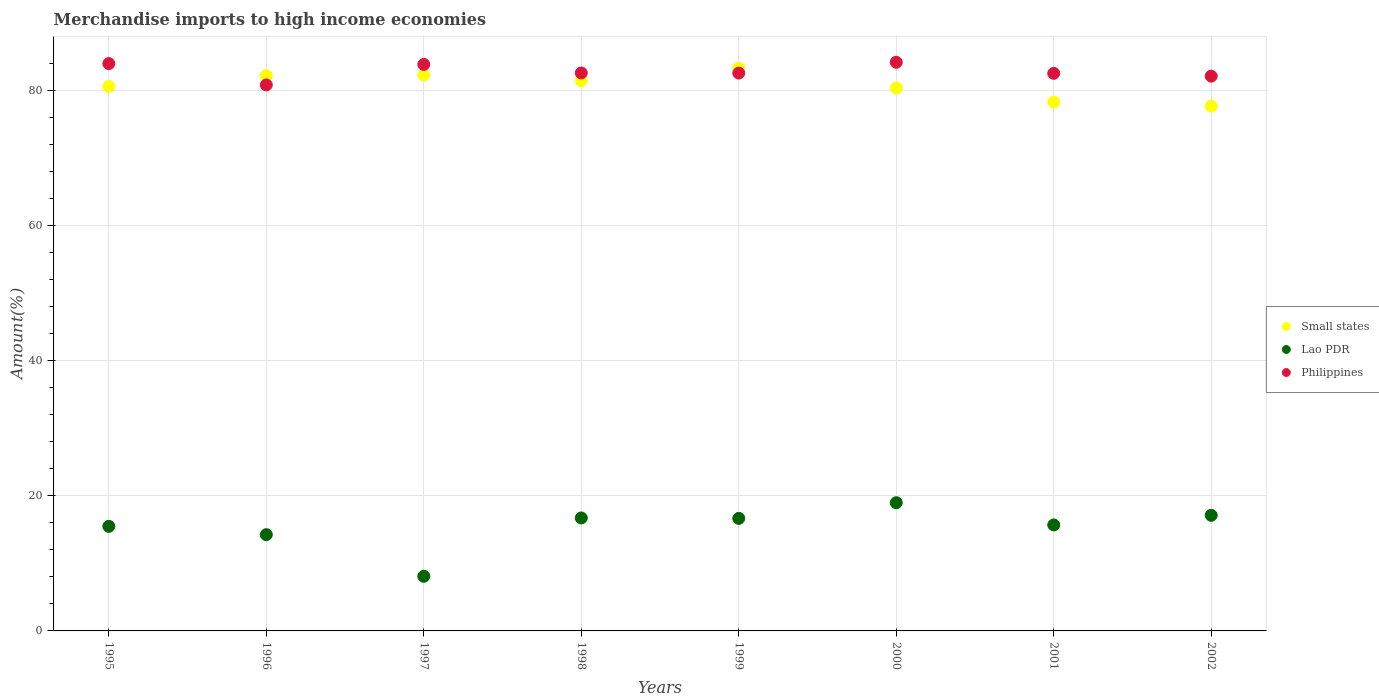What is the percentage of amount earned from merchandise imports in Lao PDR in 1997?
Your answer should be compact. 8.09. Across all years, what is the maximum percentage of amount earned from merchandise imports in Lao PDR?
Offer a terse response. 18.97. Across all years, what is the minimum percentage of amount earned from merchandise imports in Lao PDR?
Offer a very short reply. 8.09. In which year was the percentage of amount earned from merchandise imports in Small states maximum?
Your answer should be very brief. 1999. What is the total percentage of amount earned from merchandise imports in Small states in the graph?
Offer a very short reply. 645.89. What is the difference between the percentage of amount earned from merchandise imports in Small states in 1995 and that in 2002?
Your answer should be compact. 2.91. What is the difference between the percentage of amount earned from merchandise imports in Lao PDR in 2001 and the percentage of amount earned from merchandise imports in Philippines in 1996?
Provide a short and direct response. -65.1. What is the average percentage of amount earned from merchandise imports in Small states per year?
Give a very brief answer. 80.74. In the year 2002, what is the difference between the percentage of amount earned from merchandise imports in Small states and percentage of amount earned from merchandise imports in Philippines?
Your answer should be compact. -4.42. What is the ratio of the percentage of amount earned from merchandise imports in Lao PDR in 1997 to that in 2001?
Offer a very short reply. 0.52. What is the difference between the highest and the second highest percentage of amount earned from merchandise imports in Philippines?
Your answer should be compact. 0.19. What is the difference between the highest and the lowest percentage of amount earned from merchandise imports in Philippines?
Offer a terse response. 3.35. In how many years, is the percentage of amount earned from merchandise imports in Philippines greater than the average percentage of amount earned from merchandise imports in Philippines taken over all years?
Give a very brief answer. 3. Is the sum of the percentage of amount earned from merchandise imports in Small states in 1998 and 1999 greater than the maximum percentage of amount earned from merchandise imports in Philippines across all years?
Provide a succinct answer. Yes. Does the percentage of amount earned from merchandise imports in Small states monotonically increase over the years?
Keep it short and to the point. No. How many dotlines are there?
Offer a terse response. 3. How many years are there in the graph?
Offer a terse response. 8. What is the difference between two consecutive major ticks on the Y-axis?
Your response must be concise. 20. Does the graph contain any zero values?
Provide a succinct answer. No. Does the graph contain grids?
Provide a short and direct response. Yes. Where does the legend appear in the graph?
Your answer should be very brief. Center right. How are the legend labels stacked?
Offer a very short reply. Vertical. What is the title of the graph?
Your response must be concise. Merchandise imports to high income economies. Does "Nepal" appear as one of the legend labels in the graph?
Give a very brief answer. No. What is the label or title of the X-axis?
Your answer should be very brief. Years. What is the label or title of the Y-axis?
Ensure brevity in your answer.  Amount(%). What is the Amount(%) in Small states in 1995?
Provide a succinct answer. 80.57. What is the Amount(%) of Lao PDR in 1995?
Offer a very short reply. 15.47. What is the Amount(%) in Philippines in 1995?
Make the answer very short. 83.94. What is the Amount(%) of Small states in 1996?
Offer a terse response. 82.17. What is the Amount(%) in Lao PDR in 1996?
Your answer should be very brief. 14.24. What is the Amount(%) of Philippines in 1996?
Give a very brief answer. 80.78. What is the Amount(%) of Small states in 1997?
Offer a very short reply. 82.26. What is the Amount(%) of Lao PDR in 1997?
Provide a short and direct response. 8.09. What is the Amount(%) of Philippines in 1997?
Your answer should be compact. 83.81. What is the Amount(%) of Small states in 1998?
Provide a short and direct response. 81.41. What is the Amount(%) in Lao PDR in 1998?
Your response must be concise. 16.71. What is the Amount(%) of Philippines in 1998?
Keep it short and to the point. 82.56. What is the Amount(%) in Small states in 1999?
Provide a succinct answer. 83.25. What is the Amount(%) in Lao PDR in 1999?
Your answer should be compact. 16.65. What is the Amount(%) of Philippines in 1999?
Provide a succinct answer. 82.54. What is the Amount(%) in Small states in 2000?
Provide a succinct answer. 80.33. What is the Amount(%) in Lao PDR in 2000?
Make the answer very short. 18.97. What is the Amount(%) of Philippines in 2000?
Ensure brevity in your answer.  84.14. What is the Amount(%) of Small states in 2001?
Provide a succinct answer. 78.24. What is the Amount(%) in Lao PDR in 2001?
Make the answer very short. 15.68. What is the Amount(%) in Philippines in 2001?
Make the answer very short. 82.5. What is the Amount(%) of Small states in 2002?
Ensure brevity in your answer.  77.66. What is the Amount(%) in Lao PDR in 2002?
Offer a terse response. 17.1. What is the Amount(%) in Philippines in 2002?
Keep it short and to the point. 82.08. Across all years, what is the maximum Amount(%) of Small states?
Your response must be concise. 83.25. Across all years, what is the maximum Amount(%) in Lao PDR?
Provide a short and direct response. 18.97. Across all years, what is the maximum Amount(%) of Philippines?
Offer a terse response. 84.14. Across all years, what is the minimum Amount(%) in Small states?
Make the answer very short. 77.66. Across all years, what is the minimum Amount(%) in Lao PDR?
Provide a succinct answer. 8.09. Across all years, what is the minimum Amount(%) in Philippines?
Offer a very short reply. 80.78. What is the total Amount(%) of Small states in the graph?
Offer a terse response. 645.89. What is the total Amount(%) of Lao PDR in the graph?
Make the answer very short. 122.92. What is the total Amount(%) in Philippines in the graph?
Offer a very short reply. 662.35. What is the difference between the Amount(%) of Small states in 1995 and that in 1996?
Your answer should be compact. -1.61. What is the difference between the Amount(%) of Lao PDR in 1995 and that in 1996?
Your answer should be compact. 1.23. What is the difference between the Amount(%) in Philippines in 1995 and that in 1996?
Keep it short and to the point. 3.16. What is the difference between the Amount(%) of Small states in 1995 and that in 1997?
Your answer should be very brief. -1.69. What is the difference between the Amount(%) of Lao PDR in 1995 and that in 1997?
Ensure brevity in your answer.  7.39. What is the difference between the Amount(%) in Philippines in 1995 and that in 1997?
Offer a very short reply. 0.13. What is the difference between the Amount(%) in Small states in 1995 and that in 1998?
Provide a short and direct response. -0.85. What is the difference between the Amount(%) in Lao PDR in 1995 and that in 1998?
Your answer should be compact. -1.24. What is the difference between the Amount(%) in Philippines in 1995 and that in 1998?
Your answer should be compact. 1.39. What is the difference between the Amount(%) in Small states in 1995 and that in 1999?
Provide a short and direct response. -2.68. What is the difference between the Amount(%) in Lao PDR in 1995 and that in 1999?
Your response must be concise. -1.18. What is the difference between the Amount(%) of Philippines in 1995 and that in 1999?
Offer a very short reply. 1.41. What is the difference between the Amount(%) in Small states in 1995 and that in 2000?
Make the answer very short. 0.24. What is the difference between the Amount(%) of Lao PDR in 1995 and that in 2000?
Ensure brevity in your answer.  -3.5. What is the difference between the Amount(%) of Philippines in 1995 and that in 2000?
Offer a very short reply. -0.19. What is the difference between the Amount(%) in Small states in 1995 and that in 2001?
Provide a short and direct response. 2.32. What is the difference between the Amount(%) in Lao PDR in 1995 and that in 2001?
Your answer should be very brief. -0.21. What is the difference between the Amount(%) of Philippines in 1995 and that in 2001?
Your answer should be compact. 1.45. What is the difference between the Amount(%) of Small states in 1995 and that in 2002?
Offer a very short reply. 2.91. What is the difference between the Amount(%) of Lao PDR in 1995 and that in 2002?
Ensure brevity in your answer.  -1.63. What is the difference between the Amount(%) in Philippines in 1995 and that in 2002?
Provide a succinct answer. 1.86. What is the difference between the Amount(%) of Small states in 1996 and that in 1997?
Offer a very short reply. -0.08. What is the difference between the Amount(%) in Lao PDR in 1996 and that in 1997?
Provide a short and direct response. 6.15. What is the difference between the Amount(%) of Philippines in 1996 and that in 1997?
Give a very brief answer. -3.03. What is the difference between the Amount(%) of Small states in 1996 and that in 1998?
Your answer should be compact. 0.76. What is the difference between the Amount(%) in Lao PDR in 1996 and that in 1998?
Your answer should be very brief. -2.47. What is the difference between the Amount(%) in Philippines in 1996 and that in 1998?
Make the answer very short. -1.77. What is the difference between the Amount(%) in Small states in 1996 and that in 1999?
Give a very brief answer. -1.08. What is the difference between the Amount(%) in Lao PDR in 1996 and that in 1999?
Provide a short and direct response. -2.41. What is the difference between the Amount(%) in Philippines in 1996 and that in 1999?
Keep it short and to the point. -1.75. What is the difference between the Amount(%) of Small states in 1996 and that in 2000?
Provide a short and direct response. 1.85. What is the difference between the Amount(%) in Lao PDR in 1996 and that in 2000?
Offer a very short reply. -4.73. What is the difference between the Amount(%) in Philippines in 1996 and that in 2000?
Your answer should be compact. -3.35. What is the difference between the Amount(%) in Small states in 1996 and that in 2001?
Your answer should be compact. 3.93. What is the difference between the Amount(%) of Lao PDR in 1996 and that in 2001?
Make the answer very short. -1.44. What is the difference between the Amount(%) of Philippines in 1996 and that in 2001?
Offer a terse response. -1.72. What is the difference between the Amount(%) of Small states in 1996 and that in 2002?
Make the answer very short. 4.51. What is the difference between the Amount(%) in Lao PDR in 1996 and that in 2002?
Provide a short and direct response. -2.86. What is the difference between the Amount(%) of Philippines in 1996 and that in 2002?
Offer a very short reply. -1.3. What is the difference between the Amount(%) of Small states in 1997 and that in 1998?
Ensure brevity in your answer.  0.85. What is the difference between the Amount(%) in Lao PDR in 1997 and that in 1998?
Your answer should be compact. -8.63. What is the difference between the Amount(%) of Philippines in 1997 and that in 1998?
Keep it short and to the point. 1.26. What is the difference between the Amount(%) of Small states in 1997 and that in 1999?
Your response must be concise. -0.99. What is the difference between the Amount(%) in Lao PDR in 1997 and that in 1999?
Give a very brief answer. -8.57. What is the difference between the Amount(%) of Philippines in 1997 and that in 1999?
Provide a short and direct response. 1.28. What is the difference between the Amount(%) in Small states in 1997 and that in 2000?
Your response must be concise. 1.93. What is the difference between the Amount(%) of Lao PDR in 1997 and that in 2000?
Provide a succinct answer. -10.89. What is the difference between the Amount(%) of Philippines in 1997 and that in 2000?
Give a very brief answer. -0.32. What is the difference between the Amount(%) in Small states in 1997 and that in 2001?
Give a very brief answer. 4.02. What is the difference between the Amount(%) in Lao PDR in 1997 and that in 2001?
Offer a very short reply. -7.6. What is the difference between the Amount(%) of Philippines in 1997 and that in 2001?
Make the answer very short. 1.32. What is the difference between the Amount(%) in Small states in 1997 and that in 2002?
Make the answer very short. 4.6. What is the difference between the Amount(%) of Lao PDR in 1997 and that in 2002?
Make the answer very short. -9.02. What is the difference between the Amount(%) of Philippines in 1997 and that in 2002?
Ensure brevity in your answer.  1.73. What is the difference between the Amount(%) of Small states in 1998 and that in 1999?
Ensure brevity in your answer.  -1.84. What is the difference between the Amount(%) of Lao PDR in 1998 and that in 1999?
Your answer should be very brief. 0.06. What is the difference between the Amount(%) of Philippines in 1998 and that in 1999?
Your answer should be very brief. 0.02. What is the difference between the Amount(%) in Small states in 1998 and that in 2000?
Make the answer very short. 1.09. What is the difference between the Amount(%) in Lao PDR in 1998 and that in 2000?
Offer a very short reply. -2.26. What is the difference between the Amount(%) of Philippines in 1998 and that in 2000?
Your response must be concise. -1.58. What is the difference between the Amount(%) of Small states in 1998 and that in 2001?
Give a very brief answer. 3.17. What is the difference between the Amount(%) of Lao PDR in 1998 and that in 2001?
Offer a very short reply. 1.03. What is the difference between the Amount(%) of Philippines in 1998 and that in 2001?
Offer a very short reply. 0.06. What is the difference between the Amount(%) of Small states in 1998 and that in 2002?
Provide a succinct answer. 3.75. What is the difference between the Amount(%) in Lao PDR in 1998 and that in 2002?
Give a very brief answer. -0.39. What is the difference between the Amount(%) of Philippines in 1998 and that in 2002?
Provide a short and direct response. 0.47. What is the difference between the Amount(%) of Small states in 1999 and that in 2000?
Give a very brief answer. 2.92. What is the difference between the Amount(%) in Lao PDR in 1999 and that in 2000?
Offer a very short reply. -2.32. What is the difference between the Amount(%) of Philippines in 1999 and that in 2000?
Ensure brevity in your answer.  -1.6. What is the difference between the Amount(%) in Small states in 1999 and that in 2001?
Offer a terse response. 5.01. What is the difference between the Amount(%) in Lao PDR in 1999 and that in 2001?
Your response must be concise. 0.97. What is the difference between the Amount(%) in Philippines in 1999 and that in 2001?
Your answer should be compact. 0.04. What is the difference between the Amount(%) of Small states in 1999 and that in 2002?
Your answer should be compact. 5.59. What is the difference between the Amount(%) in Lao PDR in 1999 and that in 2002?
Offer a very short reply. -0.45. What is the difference between the Amount(%) of Philippines in 1999 and that in 2002?
Keep it short and to the point. 0.45. What is the difference between the Amount(%) in Small states in 2000 and that in 2001?
Offer a very short reply. 2.08. What is the difference between the Amount(%) in Lao PDR in 2000 and that in 2001?
Offer a terse response. 3.29. What is the difference between the Amount(%) of Philippines in 2000 and that in 2001?
Your response must be concise. 1.64. What is the difference between the Amount(%) of Small states in 2000 and that in 2002?
Provide a succinct answer. 2.67. What is the difference between the Amount(%) of Lao PDR in 2000 and that in 2002?
Your answer should be compact. 1.87. What is the difference between the Amount(%) in Philippines in 2000 and that in 2002?
Ensure brevity in your answer.  2.05. What is the difference between the Amount(%) in Small states in 2001 and that in 2002?
Provide a succinct answer. 0.58. What is the difference between the Amount(%) of Lao PDR in 2001 and that in 2002?
Keep it short and to the point. -1.42. What is the difference between the Amount(%) of Philippines in 2001 and that in 2002?
Your answer should be compact. 0.41. What is the difference between the Amount(%) of Small states in 1995 and the Amount(%) of Lao PDR in 1996?
Offer a very short reply. 66.33. What is the difference between the Amount(%) in Small states in 1995 and the Amount(%) in Philippines in 1996?
Provide a succinct answer. -0.22. What is the difference between the Amount(%) in Lao PDR in 1995 and the Amount(%) in Philippines in 1996?
Offer a very short reply. -65.31. What is the difference between the Amount(%) of Small states in 1995 and the Amount(%) of Lao PDR in 1997?
Give a very brief answer. 72.48. What is the difference between the Amount(%) in Small states in 1995 and the Amount(%) in Philippines in 1997?
Offer a very short reply. -3.25. What is the difference between the Amount(%) of Lao PDR in 1995 and the Amount(%) of Philippines in 1997?
Ensure brevity in your answer.  -68.34. What is the difference between the Amount(%) in Small states in 1995 and the Amount(%) in Lao PDR in 1998?
Provide a short and direct response. 63.85. What is the difference between the Amount(%) in Small states in 1995 and the Amount(%) in Philippines in 1998?
Your answer should be very brief. -1.99. What is the difference between the Amount(%) in Lao PDR in 1995 and the Amount(%) in Philippines in 1998?
Give a very brief answer. -67.08. What is the difference between the Amount(%) in Small states in 1995 and the Amount(%) in Lao PDR in 1999?
Your answer should be very brief. 63.91. What is the difference between the Amount(%) of Small states in 1995 and the Amount(%) of Philippines in 1999?
Provide a short and direct response. -1.97. What is the difference between the Amount(%) in Lao PDR in 1995 and the Amount(%) in Philippines in 1999?
Your answer should be compact. -67.06. What is the difference between the Amount(%) of Small states in 1995 and the Amount(%) of Lao PDR in 2000?
Your response must be concise. 61.59. What is the difference between the Amount(%) of Small states in 1995 and the Amount(%) of Philippines in 2000?
Your answer should be compact. -3.57. What is the difference between the Amount(%) in Lao PDR in 1995 and the Amount(%) in Philippines in 2000?
Make the answer very short. -68.66. What is the difference between the Amount(%) of Small states in 1995 and the Amount(%) of Lao PDR in 2001?
Keep it short and to the point. 64.88. What is the difference between the Amount(%) of Small states in 1995 and the Amount(%) of Philippines in 2001?
Make the answer very short. -1.93. What is the difference between the Amount(%) of Lao PDR in 1995 and the Amount(%) of Philippines in 2001?
Offer a very short reply. -67.03. What is the difference between the Amount(%) in Small states in 1995 and the Amount(%) in Lao PDR in 2002?
Keep it short and to the point. 63.46. What is the difference between the Amount(%) in Small states in 1995 and the Amount(%) in Philippines in 2002?
Your response must be concise. -1.52. What is the difference between the Amount(%) in Lao PDR in 1995 and the Amount(%) in Philippines in 2002?
Your answer should be compact. -66.61. What is the difference between the Amount(%) of Small states in 1996 and the Amount(%) of Lao PDR in 1997?
Offer a very short reply. 74.09. What is the difference between the Amount(%) of Small states in 1996 and the Amount(%) of Philippines in 1997?
Provide a short and direct response. -1.64. What is the difference between the Amount(%) of Lao PDR in 1996 and the Amount(%) of Philippines in 1997?
Your answer should be compact. -69.57. What is the difference between the Amount(%) in Small states in 1996 and the Amount(%) in Lao PDR in 1998?
Provide a succinct answer. 65.46. What is the difference between the Amount(%) in Small states in 1996 and the Amount(%) in Philippines in 1998?
Keep it short and to the point. -0.38. What is the difference between the Amount(%) in Lao PDR in 1996 and the Amount(%) in Philippines in 1998?
Give a very brief answer. -68.32. What is the difference between the Amount(%) in Small states in 1996 and the Amount(%) in Lao PDR in 1999?
Give a very brief answer. 65.52. What is the difference between the Amount(%) of Small states in 1996 and the Amount(%) of Philippines in 1999?
Offer a very short reply. -0.36. What is the difference between the Amount(%) in Lao PDR in 1996 and the Amount(%) in Philippines in 1999?
Offer a very short reply. -68.3. What is the difference between the Amount(%) in Small states in 1996 and the Amount(%) in Lao PDR in 2000?
Ensure brevity in your answer.  63.2. What is the difference between the Amount(%) in Small states in 1996 and the Amount(%) in Philippines in 2000?
Make the answer very short. -1.96. What is the difference between the Amount(%) of Lao PDR in 1996 and the Amount(%) of Philippines in 2000?
Give a very brief answer. -69.9. What is the difference between the Amount(%) of Small states in 1996 and the Amount(%) of Lao PDR in 2001?
Offer a terse response. 66.49. What is the difference between the Amount(%) in Small states in 1996 and the Amount(%) in Philippines in 2001?
Offer a terse response. -0.32. What is the difference between the Amount(%) in Lao PDR in 1996 and the Amount(%) in Philippines in 2001?
Your response must be concise. -68.26. What is the difference between the Amount(%) in Small states in 1996 and the Amount(%) in Lao PDR in 2002?
Ensure brevity in your answer.  65.07. What is the difference between the Amount(%) in Small states in 1996 and the Amount(%) in Philippines in 2002?
Offer a terse response. 0.09. What is the difference between the Amount(%) in Lao PDR in 1996 and the Amount(%) in Philippines in 2002?
Your answer should be very brief. -67.84. What is the difference between the Amount(%) of Small states in 1997 and the Amount(%) of Lao PDR in 1998?
Offer a terse response. 65.55. What is the difference between the Amount(%) in Small states in 1997 and the Amount(%) in Philippines in 1998?
Give a very brief answer. -0.3. What is the difference between the Amount(%) of Lao PDR in 1997 and the Amount(%) of Philippines in 1998?
Keep it short and to the point. -74.47. What is the difference between the Amount(%) of Small states in 1997 and the Amount(%) of Lao PDR in 1999?
Your answer should be compact. 65.61. What is the difference between the Amount(%) in Small states in 1997 and the Amount(%) in Philippines in 1999?
Ensure brevity in your answer.  -0.28. What is the difference between the Amount(%) of Lao PDR in 1997 and the Amount(%) of Philippines in 1999?
Keep it short and to the point. -74.45. What is the difference between the Amount(%) of Small states in 1997 and the Amount(%) of Lao PDR in 2000?
Your answer should be very brief. 63.29. What is the difference between the Amount(%) of Small states in 1997 and the Amount(%) of Philippines in 2000?
Give a very brief answer. -1.88. What is the difference between the Amount(%) in Lao PDR in 1997 and the Amount(%) in Philippines in 2000?
Provide a succinct answer. -76.05. What is the difference between the Amount(%) of Small states in 1997 and the Amount(%) of Lao PDR in 2001?
Provide a short and direct response. 66.58. What is the difference between the Amount(%) of Small states in 1997 and the Amount(%) of Philippines in 2001?
Your response must be concise. -0.24. What is the difference between the Amount(%) in Lao PDR in 1997 and the Amount(%) in Philippines in 2001?
Ensure brevity in your answer.  -74.41. What is the difference between the Amount(%) of Small states in 1997 and the Amount(%) of Lao PDR in 2002?
Your answer should be compact. 65.16. What is the difference between the Amount(%) in Small states in 1997 and the Amount(%) in Philippines in 2002?
Your answer should be very brief. 0.18. What is the difference between the Amount(%) of Lao PDR in 1997 and the Amount(%) of Philippines in 2002?
Your answer should be very brief. -74. What is the difference between the Amount(%) in Small states in 1998 and the Amount(%) in Lao PDR in 1999?
Give a very brief answer. 64.76. What is the difference between the Amount(%) in Small states in 1998 and the Amount(%) in Philippines in 1999?
Give a very brief answer. -1.12. What is the difference between the Amount(%) of Lao PDR in 1998 and the Amount(%) of Philippines in 1999?
Offer a terse response. -65.82. What is the difference between the Amount(%) of Small states in 1998 and the Amount(%) of Lao PDR in 2000?
Offer a very short reply. 62.44. What is the difference between the Amount(%) of Small states in 1998 and the Amount(%) of Philippines in 2000?
Provide a succinct answer. -2.72. What is the difference between the Amount(%) of Lao PDR in 1998 and the Amount(%) of Philippines in 2000?
Your response must be concise. -67.42. What is the difference between the Amount(%) of Small states in 1998 and the Amount(%) of Lao PDR in 2001?
Ensure brevity in your answer.  65.73. What is the difference between the Amount(%) in Small states in 1998 and the Amount(%) in Philippines in 2001?
Offer a terse response. -1.09. What is the difference between the Amount(%) of Lao PDR in 1998 and the Amount(%) of Philippines in 2001?
Give a very brief answer. -65.78. What is the difference between the Amount(%) in Small states in 1998 and the Amount(%) in Lao PDR in 2002?
Your answer should be compact. 64.31. What is the difference between the Amount(%) in Small states in 1998 and the Amount(%) in Philippines in 2002?
Give a very brief answer. -0.67. What is the difference between the Amount(%) in Lao PDR in 1998 and the Amount(%) in Philippines in 2002?
Provide a short and direct response. -65.37. What is the difference between the Amount(%) in Small states in 1999 and the Amount(%) in Lao PDR in 2000?
Your answer should be compact. 64.28. What is the difference between the Amount(%) of Small states in 1999 and the Amount(%) of Philippines in 2000?
Your answer should be compact. -0.89. What is the difference between the Amount(%) of Lao PDR in 1999 and the Amount(%) of Philippines in 2000?
Give a very brief answer. -67.48. What is the difference between the Amount(%) of Small states in 1999 and the Amount(%) of Lao PDR in 2001?
Provide a succinct answer. 67.57. What is the difference between the Amount(%) of Small states in 1999 and the Amount(%) of Philippines in 2001?
Keep it short and to the point. 0.75. What is the difference between the Amount(%) in Lao PDR in 1999 and the Amount(%) in Philippines in 2001?
Give a very brief answer. -65.85. What is the difference between the Amount(%) in Small states in 1999 and the Amount(%) in Lao PDR in 2002?
Provide a succinct answer. 66.15. What is the difference between the Amount(%) in Small states in 1999 and the Amount(%) in Philippines in 2002?
Offer a terse response. 1.17. What is the difference between the Amount(%) of Lao PDR in 1999 and the Amount(%) of Philippines in 2002?
Give a very brief answer. -65.43. What is the difference between the Amount(%) of Small states in 2000 and the Amount(%) of Lao PDR in 2001?
Keep it short and to the point. 64.64. What is the difference between the Amount(%) of Small states in 2000 and the Amount(%) of Philippines in 2001?
Offer a very short reply. -2.17. What is the difference between the Amount(%) of Lao PDR in 2000 and the Amount(%) of Philippines in 2001?
Your response must be concise. -63.53. What is the difference between the Amount(%) in Small states in 2000 and the Amount(%) in Lao PDR in 2002?
Keep it short and to the point. 63.22. What is the difference between the Amount(%) in Small states in 2000 and the Amount(%) in Philippines in 2002?
Make the answer very short. -1.76. What is the difference between the Amount(%) in Lao PDR in 2000 and the Amount(%) in Philippines in 2002?
Keep it short and to the point. -63.11. What is the difference between the Amount(%) in Small states in 2001 and the Amount(%) in Lao PDR in 2002?
Keep it short and to the point. 61.14. What is the difference between the Amount(%) in Small states in 2001 and the Amount(%) in Philippines in 2002?
Ensure brevity in your answer.  -3.84. What is the difference between the Amount(%) of Lao PDR in 2001 and the Amount(%) of Philippines in 2002?
Your response must be concise. -66.4. What is the average Amount(%) in Small states per year?
Your answer should be compact. 80.74. What is the average Amount(%) in Lao PDR per year?
Provide a short and direct response. 15.36. What is the average Amount(%) in Philippines per year?
Ensure brevity in your answer.  82.79. In the year 1995, what is the difference between the Amount(%) in Small states and Amount(%) in Lao PDR?
Keep it short and to the point. 65.09. In the year 1995, what is the difference between the Amount(%) in Small states and Amount(%) in Philippines?
Offer a terse response. -3.38. In the year 1995, what is the difference between the Amount(%) in Lao PDR and Amount(%) in Philippines?
Offer a terse response. -68.47. In the year 1996, what is the difference between the Amount(%) of Small states and Amount(%) of Lao PDR?
Make the answer very short. 67.93. In the year 1996, what is the difference between the Amount(%) in Small states and Amount(%) in Philippines?
Provide a short and direct response. 1.39. In the year 1996, what is the difference between the Amount(%) in Lao PDR and Amount(%) in Philippines?
Provide a succinct answer. -66.54. In the year 1997, what is the difference between the Amount(%) of Small states and Amount(%) of Lao PDR?
Your answer should be compact. 74.17. In the year 1997, what is the difference between the Amount(%) in Small states and Amount(%) in Philippines?
Ensure brevity in your answer.  -1.56. In the year 1997, what is the difference between the Amount(%) in Lao PDR and Amount(%) in Philippines?
Provide a short and direct response. -75.73. In the year 1998, what is the difference between the Amount(%) of Small states and Amount(%) of Lao PDR?
Give a very brief answer. 64.7. In the year 1998, what is the difference between the Amount(%) in Small states and Amount(%) in Philippines?
Give a very brief answer. -1.14. In the year 1998, what is the difference between the Amount(%) of Lao PDR and Amount(%) of Philippines?
Ensure brevity in your answer.  -65.84. In the year 1999, what is the difference between the Amount(%) of Small states and Amount(%) of Lao PDR?
Offer a very short reply. 66.6. In the year 1999, what is the difference between the Amount(%) in Lao PDR and Amount(%) in Philippines?
Offer a terse response. -65.88. In the year 2000, what is the difference between the Amount(%) of Small states and Amount(%) of Lao PDR?
Provide a succinct answer. 61.36. In the year 2000, what is the difference between the Amount(%) of Small states and Amount(%) of Philippines?
Provide a short and direct response. -3.81. In the year 2000, what is the difference between the Amount(%) in Lao PDR and Amount(%) in Philippines?
Your answer should be compact. -65.17. In the year 2001, what is the difference between the Amount(%) of Small states and Amount(%) of Lao PDR?
Offer a terse response. 62.56. In the year 2001, what is the difference between the Amount(%) in Small states and Amount(%) in Philippines?
Offer a very short reply. -4.26. In the year 2001, what is the difference between the Amount(%) in Lao PDR and Amount(%) in Philippines?
Provide a short and direct response. -66.81. In the year 2002, what is the difference between the Amount(%) of Small states and Amount(%) of Lao PDR?
Your answer should be very brief. 60.56. In the year 2002, what is the difference between the Amount(%) of Small states and Amount(%) of Philippines?
Offer a very short reply. -4.42. In the year 2002, what is the difference between the Amount(%) in Lao PDR and Amount(%) in Philippines?
Your response must be concise. -64.98. What is the ratio of the Amount(%) of Small states in 1995 to that in 1996?
Your response must be concise. 0.98. What is the ratio of the Amount(%) of Lao PDR in 1995 to that in 1996?
Provide a short and direct response. 1.09. What is the ratio of the Amount(%) of Philippines in 1995 to that in 1996?
Keep it short and to the point. 1.04. What is the ratio of the Amount(%) of Small states in 1995 to that in 1997?
Ensure brevity in your answer.  0.98. What is the ratio of the Amount(%) in Lao PDR in 1995 to that in 1997?
Your answer should be very brief. 1.91. What is the ratio of the Amount(%) of Small states in 1995 to that in 1998?
Offer a terse response. 0.99. What is the ratio of the Amount(%) of Lao PDR in 1995 to that in 1998?
Make the answer very short. 0.93. What is the ratio of the Amount(%) in Philippines in 1995 to that in 1998?
Make the answer very short. 1.02. What is the ratio of the Amount(%) of Small states in 1995 to that in 1999?
Give a very brief answer. 0.97. What is the ratio of the Amount(%) of Lao PDR in 1995 to that in 1999?
Make the answer very short. 0.93. What is the ratio of the Amount(%) in Philippines in 1995 to that in 1999?
Your answer should be very brief. 1.02. What is the ratio of the Amount(%) of Lao PDR in 1995 to that in 2000?
Keep it short and to the point. 0.82. What is the ratio of the Amount(%) of Small states in 1995 to that in 2001?
Give a very brief answer. 1.03. What is the ratio of the Amount(%) of Lao PDR in 1995 to that in 2001?
Make the answer very short. 0.99. What is the ratio of the Amount(%) in Philippines in 1995 to that in 2001?
Provide a succinct answer. 1.02. What is the ratio of the Amount(%) of Small states in 1995 to that in 2002?
Give a very brief answer. 1.04. What is the ratio of the Amount(%) in Lao PDR in 1995 to that in 2002?
Make the answer very short. 0.9. What is the ratio of the Amount(%) in Philippines in 1995 to that in 2002?
Keep it short and to the point. 1.02. What is the ratio of the Amount(%) of Lao PDR in 1996 to that in 1997?
Provide a succinct answer. 1.76. What is the ratio of the Amount(%) of Philippines in 1996 to that in 1997?
Give a very brief answer. 0.96. What is the ratio of the Amount(%) of Small states in 1996 to that in 1998?
Your response must be concise. 1.01. What is the ratio of the Amount(%) of Lao PDR in 1996 to that in 1998?
Provide a short and direct response. 0.85. What is the ratio of the Amount(%) in Philippines in 1996 to that in 1998?
Offer a very short reply. 0.98. What is the ratio of the Amount(%) in Small states in 1996 to that in 1999?
Provide a succinct answer. 0.99. What is the ratio of the Amount(%) in Lao PDR in 1996 to that in 1999?
Keep it short and to the point. 0.86. What is the ratio of the Amount(%) of Philippines in 1996 to that in 1999?
Your response must be concise. 0.98. What is the ratio of the Amount(%) of Small states in 1996 to that in 2000?
Ensure brevity in your answer.  1.02. What is the ratio of the Amount(%) in Lao PDR in 1996 to that in 2000?
Make the answer very short. 0.75. What is the ratio of the Amount(%) of Philippines in 1996 to that in 2000?
Your response must be concise. 0.96. What is the ratio of the Amount(%) in Small states in 1996 to that in 2001?
Offer a very short reply. 1.05. What is the ratio of the Amount(%) of Lao PDR in 1996 to that in 2001?
Keep it short and to the point. 0.91. What is the ratio of the Amount(%) of Philippines in 1996 to that in 2001?
Provide a short and direct response. 0.98. What is the ratio of the Amount(%) of Small states in 1996 to that in 2002?
Make the answer very short. 1.06. What is the ratio of the Amount(%) in Lao PDR in 1996 to that in 2002?
Your response must be concise. 0.83. What is the ratio of the Amount(%) of Philippines in 1996 to that in 2002?
Offer a very short reply. 0.98. What is the ratio of the Amount(%) of Small states in 1997 to that in 1998?
Your answer should be very brief. 1.01. What is the ratio of the Amount(%) in Lao PDR in 1997 to that in 1998?
Provide a short and direct response. 0.48. What is the ratio of the Amount(%) in Philippines in 1997 to that in 1998?
Offer a very short reply. 1.02. What is the ratio of the Amount(%) in Small states in 1997 to that in 1999?
Offer a very short reply. 0.99. What is the ratio of the Amount(%) in Lao PDR in 1997 to that in 1999?
Keep it short and to the point. 0.49. What is the ratio of the Amount(%) in Philippines in 1997 to that in 1999?
Offer a very short reply. 1.02. What is the ratio of the Amount(%) of Small states in 1997 to that in 2000?
Provide a short and direct response. 1.02. What is the ratio of the Amount(%) in Lao PDR in 1997 to that in 2000?
Your response must be concise. 0.43. What is the ratio of the Amount(%) in Philippines in 1997 to that in 2000?
Offer a very short reply. 1. What is the ratio of the Amount(%) in Small states in 1997 to that in 2001?
Your response must be concise. 1.05. What is the ratio of the Amount(%) of Lao PDR in 1997 to that in 2001?
Offer a very short reply. 0.52. What is the ratio of the Amount(%) in Philippines in 1997 to that in 2001?
Make the answer very short. 1.02. What is the ratio of the Amount(%) in Small states in 1997 to that in 2002?
Offer a terse response. 1.06. What is the ratio of the Amount(%) of Lao PDR in 1997 to that in 2002?
Ensure brevity in your answer.  0.47. What is the ratio of the Amount(%) of Philippines in 1997 to that in 2002?
Give a very brief answer. 1.02. What is the ratio of the Amount(%) of Small states in 1998 to that in 1999?
Your answer should be compact. 0.98. What is the ratio of the Amount(%) of Lao PDR in 1998 to that in 1999?
Offer a very short reply. 1. What is the ratio of the Amount(%) of Small states in 1998 to that in 2000?
Provide a succinct answer. 1.01. What is the ratio of the Amount(%) in Lao PDR in 1998 to that in 2000?
Provide a short and direct response. 0.88. What is the ratio of the Amount(%) of Philippines in 1998 to that in 2000?
Make the answer very short. 0.98. What is the ratio of the Amount(%) in Small states in 1998 to that in 2001?
Offer a very short reply. 1.04. What is the ratio of the Amount(%) in Lao PDR in 1998 to that in 2001?
Your answer should be compact. 1.07. What is the ratio of the Amount(%) in Philippines in 1998 to that in 2001?
Keep it short and to the point. 1. What is the ratio of the Amount(%) of Small states in 1998 to that in 2002?
Make the answer very short. 1.05. What is the ratio of the Amount(%) of Lao PDR in 1998 to that in 2002?
Keep it short and to the point. 0.98. What is the ratio of the Amount(%) in Philippines in 1998 to that in 2002?
Keep it short and to the point. 1.01. What is the ratio of the Amount(%) in Small states in 1999 to that in 2000?
Ensure brevity in your answer.  1.04. What is the ratio of the Amount(%) of Lao PDR in 1999 to that in 2000?
Give a very brief answer. 0.88. What is the ratio of the Amount(%) in Philippines in 1999 to that in 2000?
Your answer should be compact. 0.98. What is the ratio of the Amount(%) of Small states in 1999 to that in 2001?
Provide a short and direct response. 1.06. What is the ratio of the Amount(%) in Lao PDR in 1999 to that in 2001?
Keep it short and to the point. 1.06. What is the ratio of the Amount(%) in Small states in 1999 to that in 2002?
Ensure brevity in your answer.  1.07. What is the ratio of the Amount(%) of Lao PDR in 1999 to that in 2002?
Give a very brief answer. 0.97. What is the ratio of the Amount(%) in Philippines in 1999 to that in 2002?
Provide a succinct answer. 1.01. What is the ratio of the Amount(%) in Small states in 2000 to that in 2001?
Provide a short and direct response. 1.03. What is the ratio of the Amount(%) in Lao PDR in 2000 to that in 2001?
Give a very brief answer. 1.21. What is the ratio of the Amount(%) of Philippines in 2000 to that in 2001?
Your response must be concise. 1.02. What is the ratio of the Amount(%) in Small states in 2000 to that in 2002?
Your answer should be very brief. 1.03. What is the ratio of the Amount(%) in Lao PDR in 2000 to that in 2002?
Give a very brief answer. 1.11. What is the ratio of the Amount(%) of Philippines in 2000 to that in 2002?
Provide a short and direct response. 1.02. What is the ratio of the Amount(%) of Small states in 2001 to that in 2002?
Give a very brief answer. 1.01. What is the ratio of the Amount(%) in Lao PDR in 2001 to that in 2002?
Offer a terse response. 0.92. What is the ratio of the Amount(%) of Philippines in 2001 to that in 2002?
Give a very brief answer. 1.01. What is the difference between the highest and the second highest Amount(%) of Small states?
Offer a terse response. 0.99. What is the difference between the highest and the second highest Amount(%) of Lao PDR?
Your answer should be very brief. 1.87. What is the difference between the highest and the second highest Amount(%) of Philippines?
Provide a succinct answer. 0.19. What is the difference between the highest and the lowest Amount(%) of Small states?
Keep it short and to the point. 5.59. What is the difference between the highest and the lowest Amount(%) of Lao PDR?
Provide a short and direct response. 10.89. What is the difference between the highest and the lowest Amount(%) in Philippines?
Make the answer very short. 3.35. 